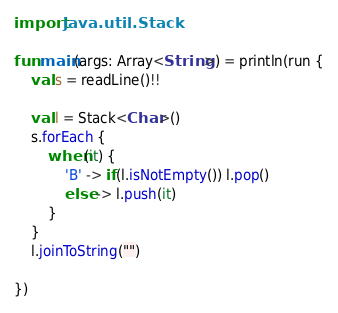Convert code to text. <code><loc_0><loc_0><loc_500><loc_500><_Kotlin_>import java.util.Stack

fun main(args: Array<String>) = println(run {
    val s = readLine()!!

    val l = Stack<Char>()
    s.forEach {
        when(it) {
            'B' -> if(l.isNotEmpty()) l.pop()
            else -> l.push(it)
        }
    }
    l.joinToString("")

})</code> 